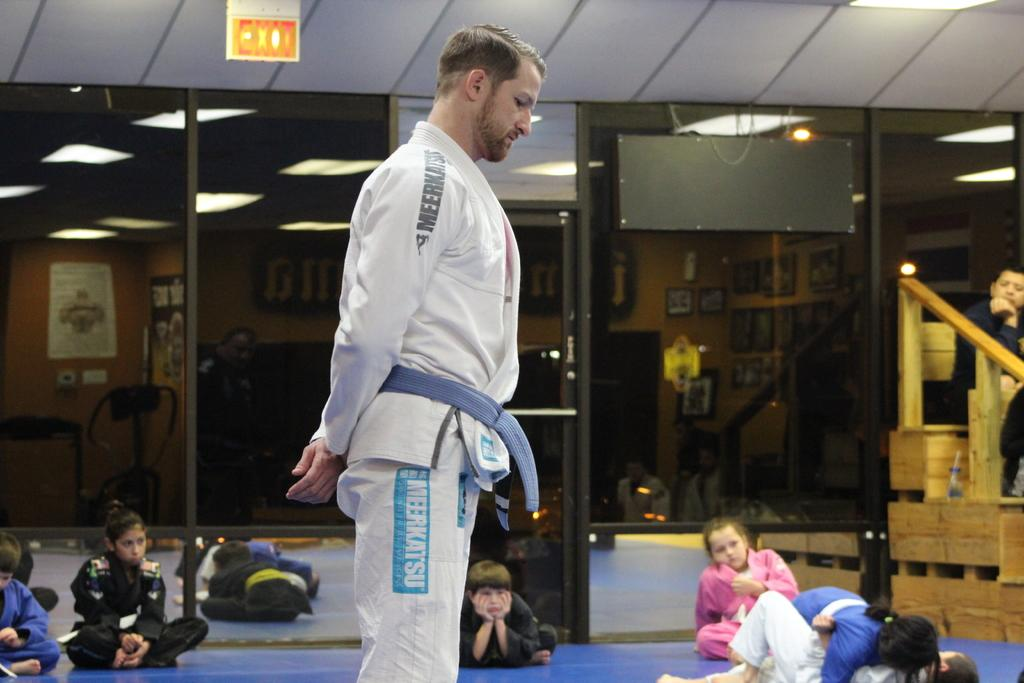What is the primary action of the person in the image? There is a person standing in the image. What is the position of the other people in the image? There are people sitting on the floor in the image. What type of architectural feature can be seen in the background? There is a glass wall in the background of the image. What part of the room is visible at the top of the image? There is a ceiling visible at the top of the image. Can you see the seashore through the glass wall in the image? There is no seashore visible in the image; it only shows a person standing, people sitting on the floor, a glass wall, and a ceiling. What type of work is the secretary doing in the image? There is no secretary present in the image. 